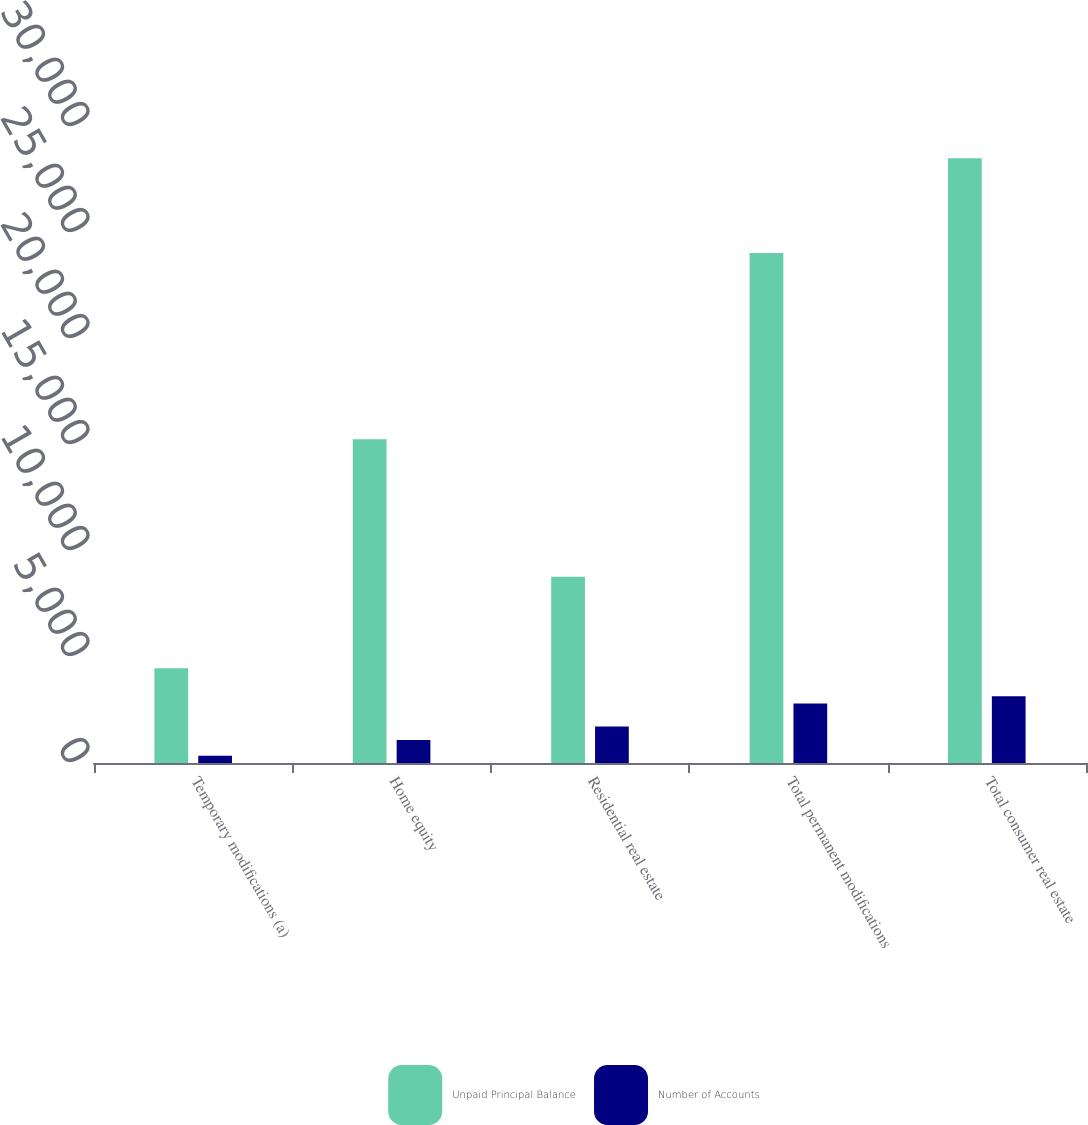Convert chart. <chart><loc_0><loc_0><loc_500><loc_500><stacked_bar_chart><ecel><fcel>Temporary modifications (a)<fcel>Home equity<fcel>Residential real estate<fcel>Total permanent modifications<fcel>Total consumer real estate<nl><fcel>Unpaid Principal Balance<fcel>4469<fcel>15268<fcel>8787<fcel>24055<fcel>28524<nl><fcel>Number of Accounts<fcel>337<fcel>1088<fcel>1721<fcel>2809<fcel>3146<nl></chart> 